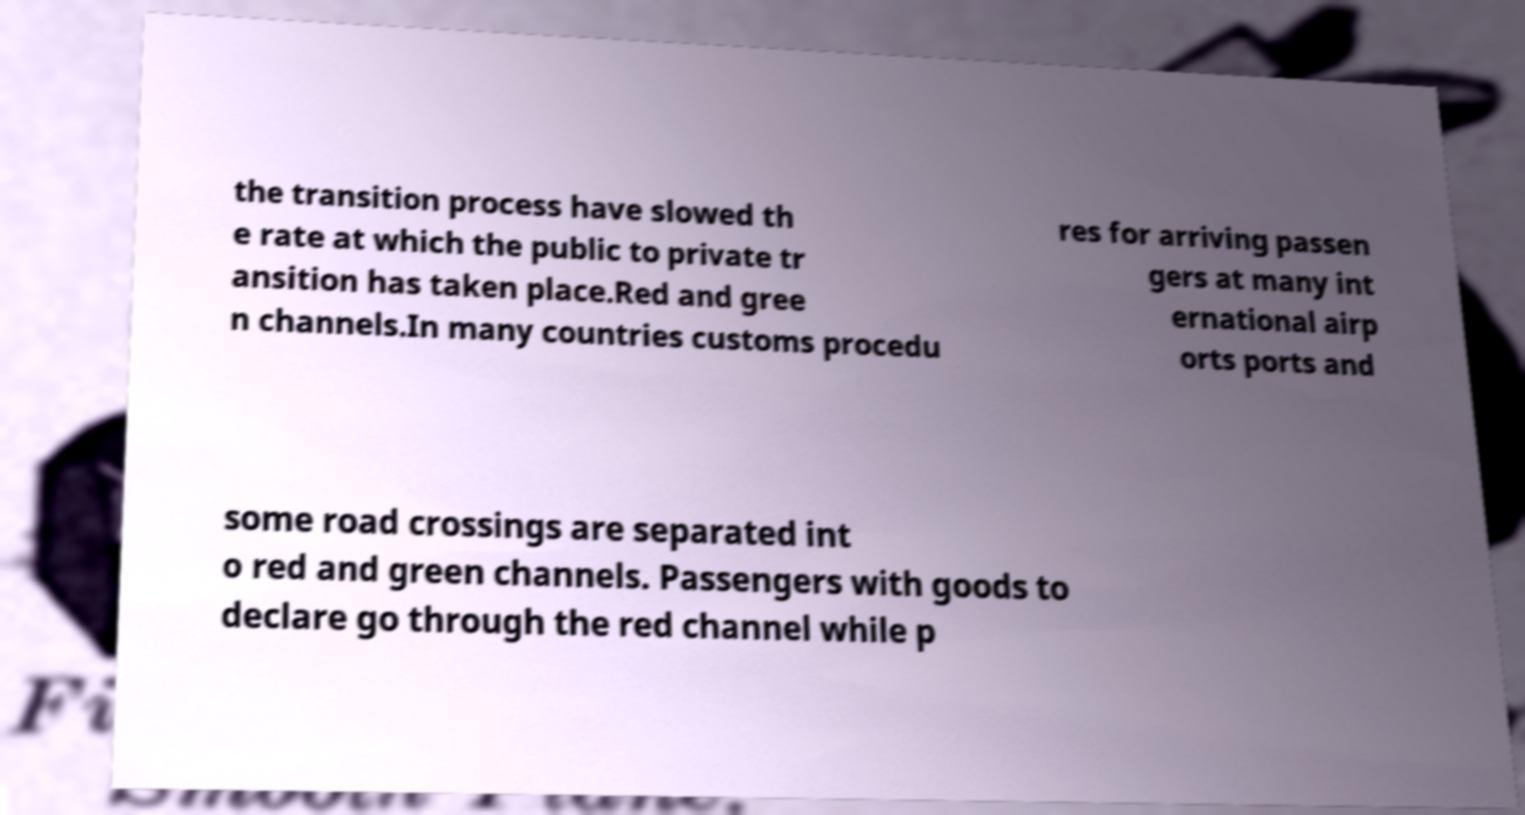What messages or text are displayed in this image? I need them in a readable, typed format. the transition process have slowed th e rate at which the public to private tr ansition has taken place.Red and gree n channels.In many countries customs procedu res for arriving passen gers at many int ernational airp orts ports and some road crossings are separated int o red and green channels. Passengers with goods to declare go through the red channel while p 